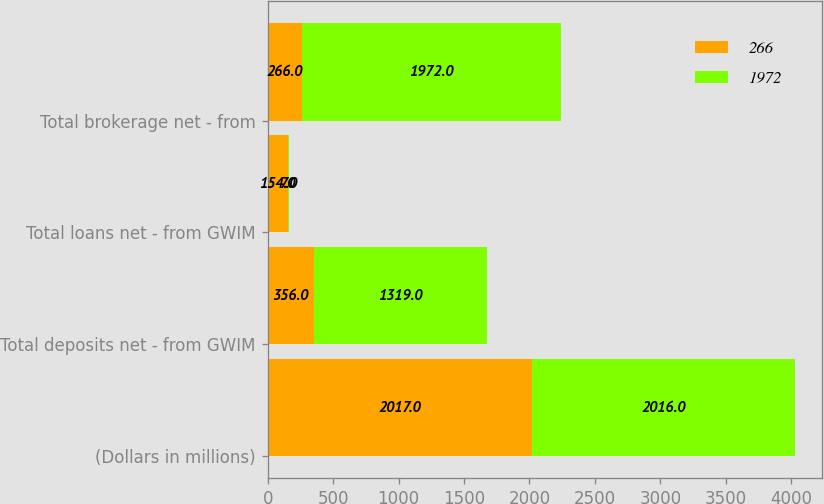Convert chart. <chart><loc_0><loc_0><loc_500><loc_500><stacked_bar_chart><ecel><fcel>(Dollars in millions)<fcel>Total deposits net - from GWIM<fcel>Total loans net - from GWIM<fcel>Total brokerage net - from<nl><fcel>266<fcel>2017<fcel>356<fcel>154<fcel>266<nl><fcel>1972<fcel>2016<fcel>1319<fcel>7<fcel>1972<nl></chart> 